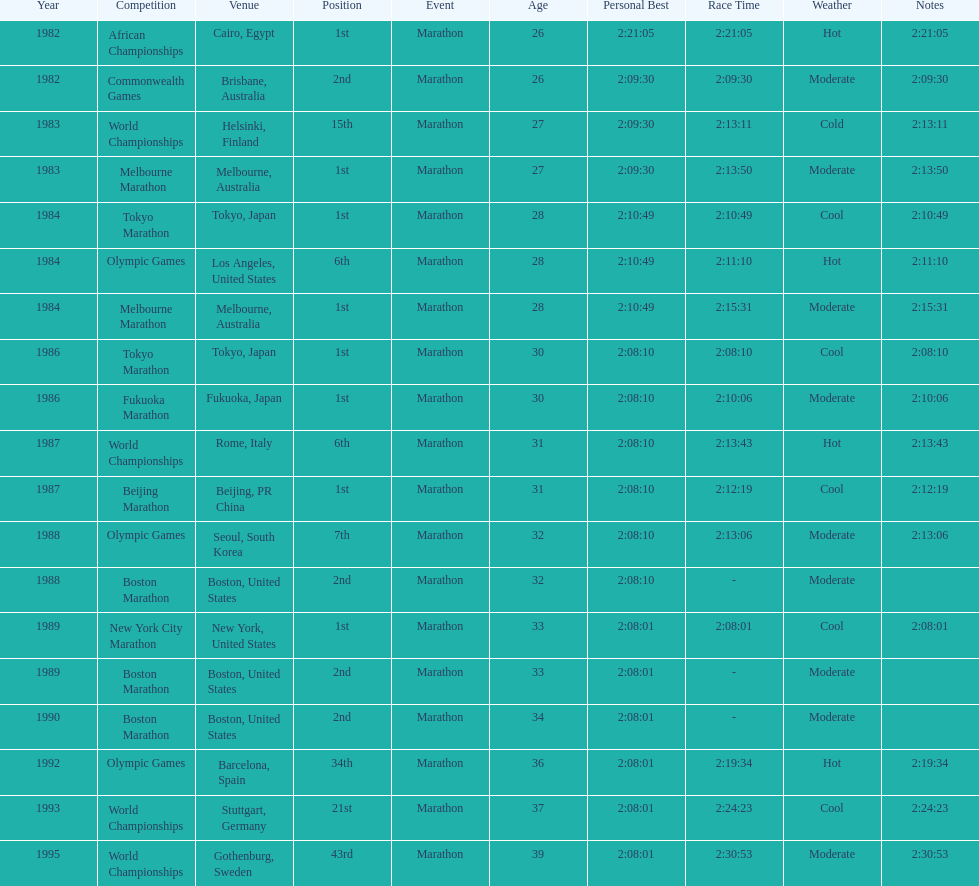Which competition is listed the most in this chart? World Championships. 